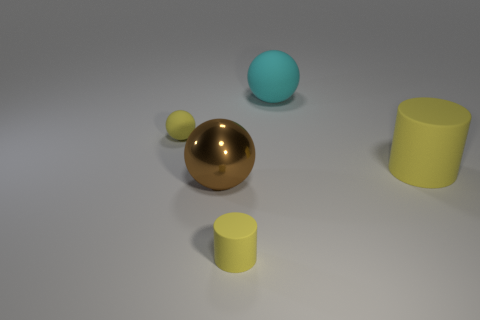Add 1 large shiny objects. How many objects exist? 6 Subtract all cylinders. How many objects are left? 3 Add 5 purple shiny balls. How many purple shiny balls exist? 5 Subtract 0 blue cylinders. How many objects are left? 5 Subtract all tiny gray cylinders. Subtract all large yellow things. How many objects are left? 4 Add 2 small yellow matte things. How many small yellow matte things are left? 4 